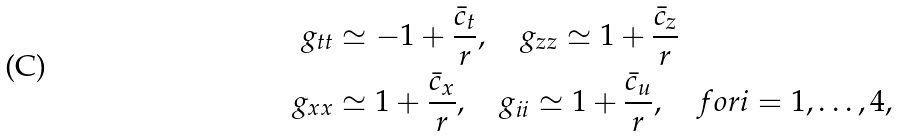Convert formula to latex. <formula><loc_0><loc_0><loc_500><loc_500>g _ { t t } & \simeq - 1 + \frac { \bar { c } _ { t } } { r } , \quad g _ { z z } \simeq 1 + \frac { \bar { c } _ { z } } { r } \\ g _ { x x } & \simeq 1 + \frac { \bar { c } _ { x } } { r } , \quad g _ { i i } \simeq 1 + \frac { \bar { c } _ { u } } { r } , \quad f o r i = 1 , \dots , 4 ,</formula> 